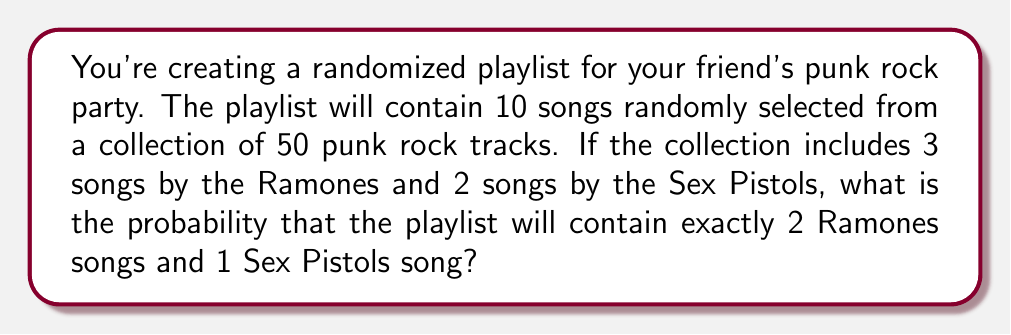Can you solve this math problem? Let's approach this step-by-step using the hypergeometric distribution:

1) We need to choose 2 Ramones songs out of 3, 1 Sex Pistols song out of 2, and 7 other songs out of the remaining 45.

2) The probability is calculated as:

   $$P = \frac{\binom{3}{2} \cdot \binom{2}{1} \cdot \binom{45}{7}}{\binom{50}{10}}$$

3) Let's calculate each combination:
   
   $\binom{3}{2} = 3$
   $\binom{2}{1} = 2$
   $\binom{45}{7} = 45!/(7!(45-7)!) = 45!/(7!38!) = 26,978,328$
   $\binom{50}{10} = 50!/(10!(50-10)!) = 50!/(10!40!) = 10,272,278,170$

4) Now, let's substitute these values:

   $$P = \frac{3 \cdot 2 \cdot 26,978,328}{10,272,278,170}$$

5) Simplify:
   
   $$P = \frac{161,869,968}{10,272,278,170} \approx 0.01576$$

Therefore, the probability is approximately 0.01576 or about 1.576%.
Answer: $\frac{161,869,968}{10,272,278,170} \approx 0.01576$ or approximately 1.576% 